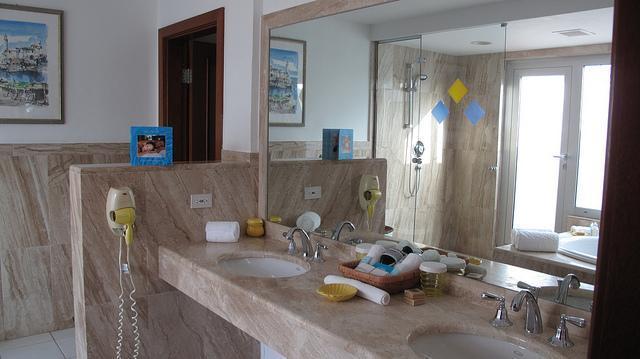How many sinks are there?
Give a very brief answer. 2. 